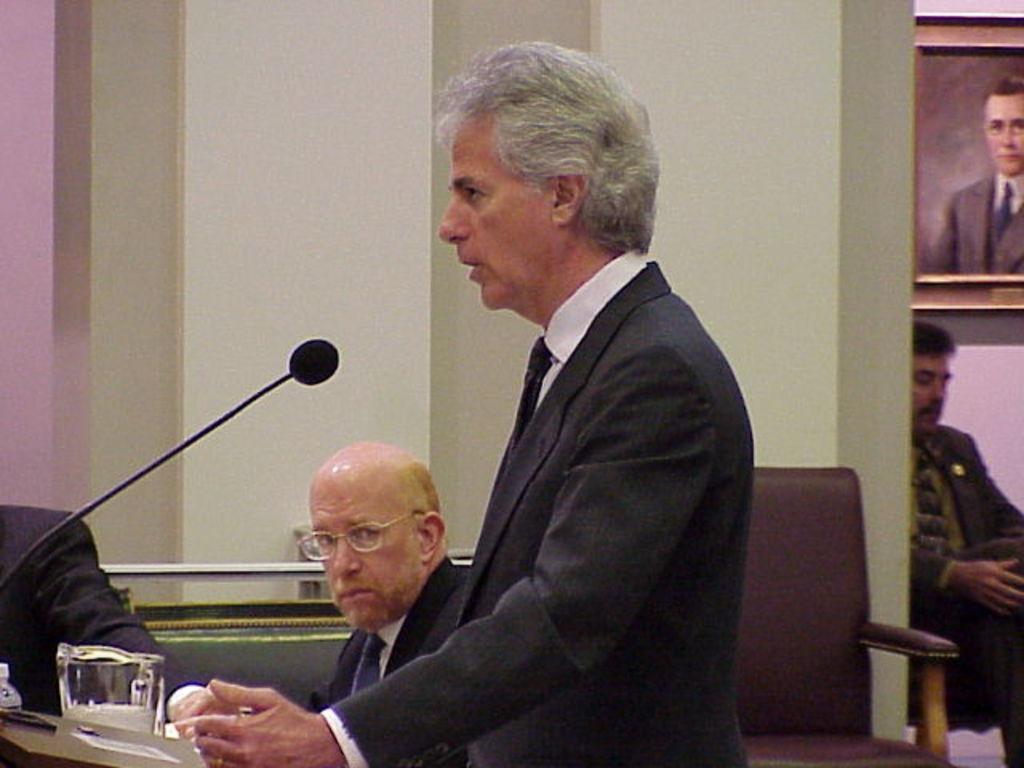Please provide a concise description of this image. In this image, there is a person wearing clothes and standing in front of the mic. There is a person at the bottom of the image wearing spectacles. There is a chair in the bottom right of the image. There is a photo frame in the top right of the image. There is an another person on the right side of the image sitting and wearing clothes. 